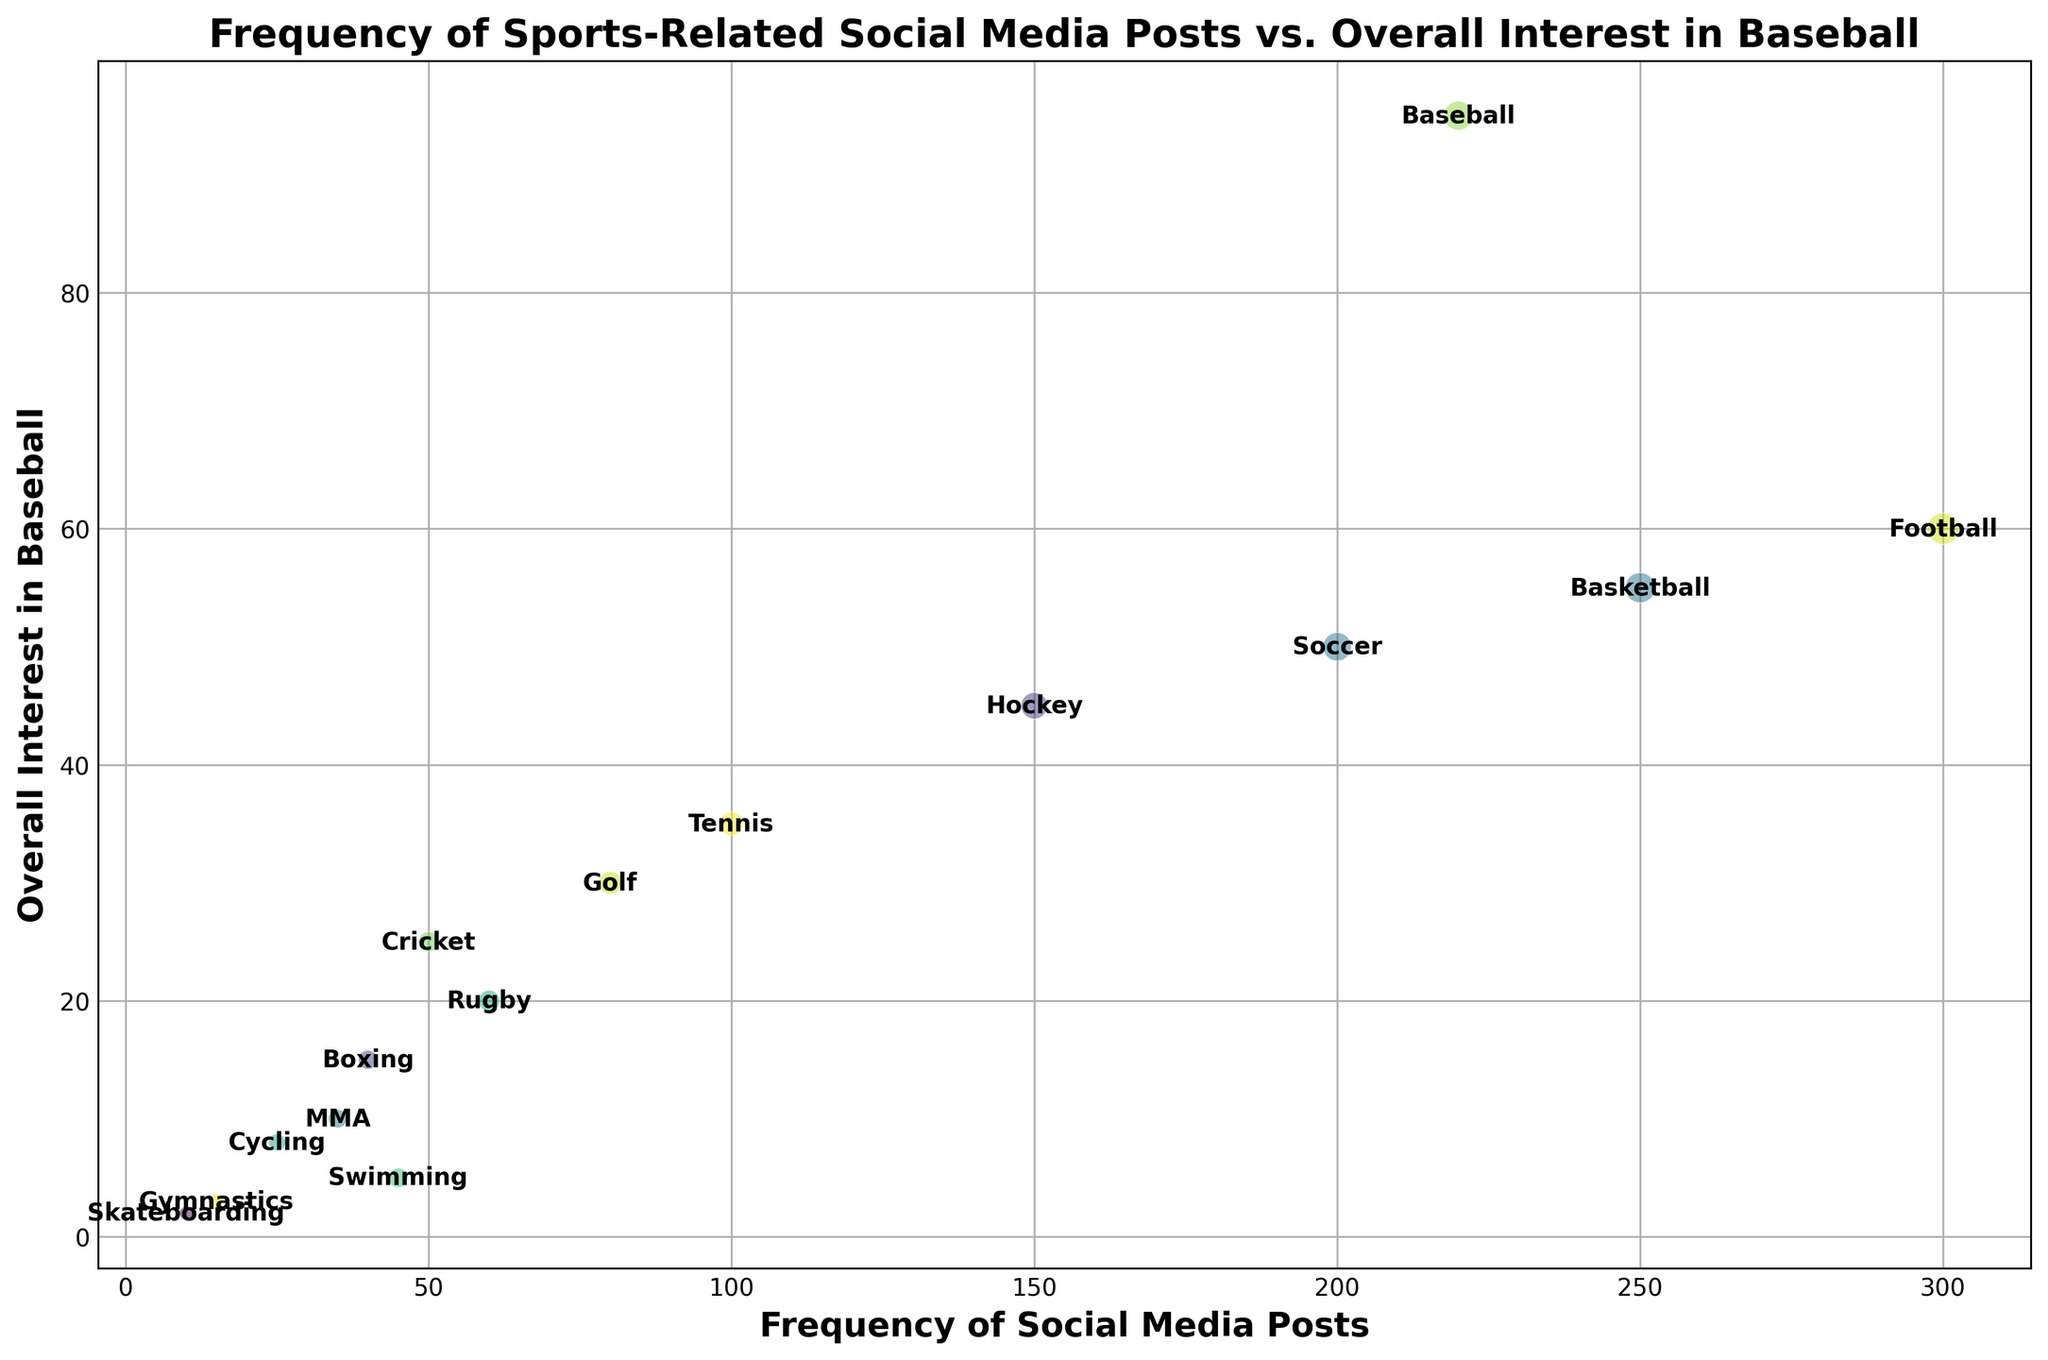Which sport has the highest overall interest in baseball? The bubble chart shows the overall interest in baseball, which is highest at the point labeled "Baseball".
Answer: Baseball Which two sports have the biggest difference in the frequency of social media posts? Look for the two furthest apart data points on the x-axis. Football (300 posts) and Skateboarding (10 posts) have the largest difference. Difference = 300 - 10 = 290.
Answer: Football and Skateboarding Is there any sport with a higher overall interest in baseball than Baseball? Check the y-axis values. The maximum overall interest in baseball is 95 for Baseball. No other sport exceeds this value.
Answer: No How many sports have a frequency of social media posts greater than 150? Count the bubbles with x-axis values greater than 150. These are Football, Basketball, Soccer, and Baseball.
Answer: 4 What is the overall interest in baseball for sports with less than 50 social media posts? Identify sports with x-values less than 50 and check their y-values. They are Cricket (25), Rugby (20), Boxing (15), MMA (10), Swimming (5), Cycling (8), Gymnastics (3), and Skateboarding (2).
Answer: Cricket: 25, Rugby: 20, Boxing: 15, MMA: 10, Swimming: 5, Cycling: 8, Gymnastics: 3, Skateboarding: 2 Do more frequently posted sports on social media have higher overall interest in baseball? Investigate the correlation by comparing the spread of bubbles on the x-axis and y-axis. Higher frequency (right-side bubbles except Baseball which has the highest y-value) does not necessarily equate to higher interest in baseball for most sports.
Answer: No What is the average overall interest in baseball for the top 3 sports in terms of social media posts? Top 3 in social media posts are Football (60), Basketball (55), and Baseball (95). Average = (60 + 55 + 95) / 3 = 210 / 3 = 70.
Answer: 70 Which sport has the smallest bubble size? Bubble sizes are based on social media posts; Skateboarding has the least posts (10), resulting in the smallest bubble.
Answer: Skateboarding 